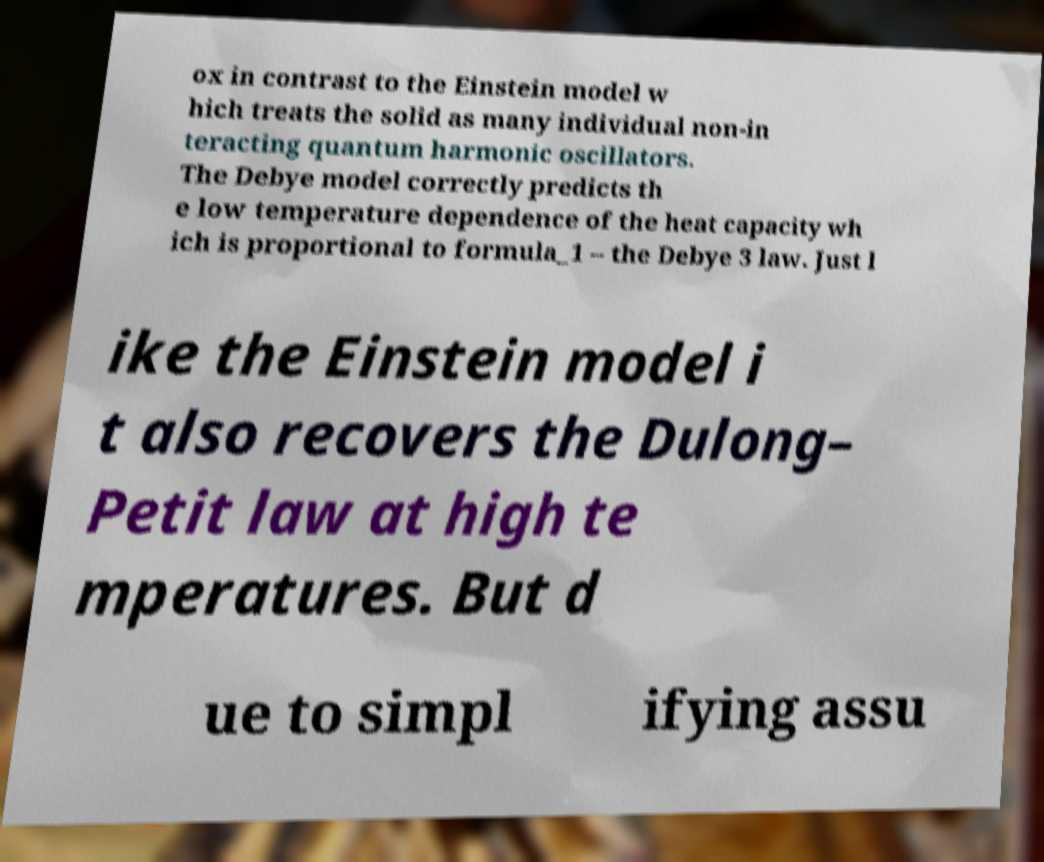Could you extract and type out the text from this image? ox in contrast to the Einstein model w hich treats the solid as many individual non-in teracting quantum harmonic oscillators. The Debye model correctly predicts th e low temperature dependence of the heat capacity wh ich is proportional to formula_1 – the Debye 3 law. Just l ike the Einstein model i t also recovers the Dulong– Petit law at high te mperatures. But d ue to simpl ifying assu 